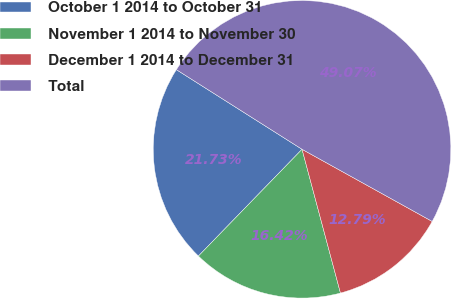Convert chart to OTSL. <chart><loc_0><loc_0><loc_500><loc_500><pie_chart><fcel>October 1 2014 to October 31<fcel>November 1 2014 to November 30<fcel>December 1 2014 to December 31<fcel>Total<nl><fcel>21.73%<fcel>16.42%<fcel>12.79%<fcel>49.07%<nl></chart> 